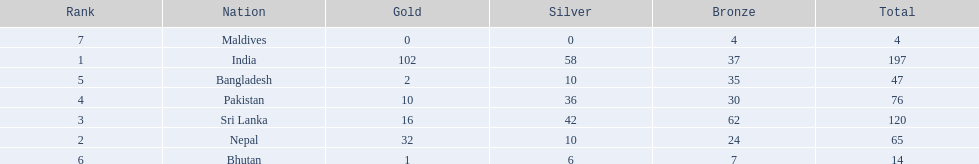What is the difference in total number of medals between india and nepal? 132. 